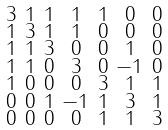Convert formula to latex. <formula><loc_0><loc_0><loc_500><loc_500>\begin{smallmatrix} 3 & 1 & 1 & 1 & 1 & 0 & 0 \\ 1 & 3 & 1 & 1 & 0 & 0 & 0 \\ 1 & 1 & 3 & 0 & 0 & 1 & 0 \\ 1 & 1 & 0 & 3 & 0 & - 1 & 0 \\ 1 & 0 & 0 & 0 & 3 & 1 & 1 \\ 0 & 0 & 1 & - 1 & 1 & 3 & 1 \\ 0 & 0 & 0 & 0 & 1 & 1 & 3 \end{smallmatrix}</formula> 